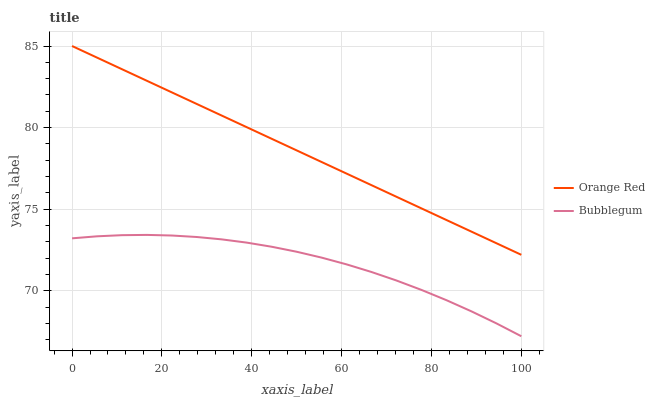Does Bubblegum have the minimum area under the curve?
Answer yes or no. Yes. Does Orange Red have the maximum area under the curve?
Answer yes or no. Yes. Does Bubblegum have the maximum area under the curve?
Answer yes or no. No. Is Orange Red the smoothest?
Answer yes or no. Yes. Is Bubblegum the roughest?
Answer yes or no. Yes. Is Bubblegum the smoothest?
Answer yes or no. No. Does Bubblegum have the lowest value?
Answer yes or no. Yes. Does Orange Red have the highest value?
Answer yes or no. Yes. Does Bubblegum have the highest value?
Answer yes or no. No. Is Bubblegum less than Orange Red?
Answer yes or no. Yes. Is Orange Red greater than Bubblegum?
Answer yes or no. Yes. Does Bubblegum intersect Orange Red?
Answer yes or no. No. 